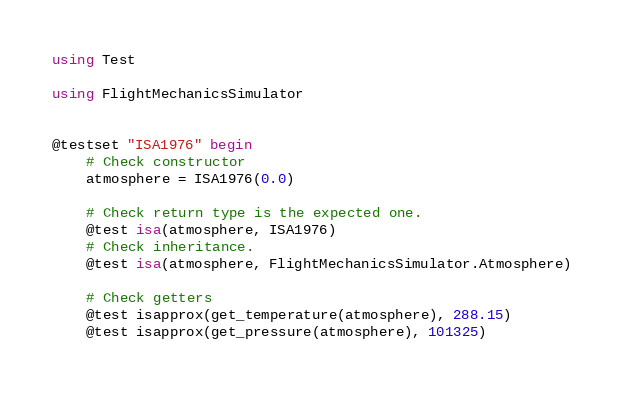<code> <loc_0><loc_0><loc_500><loc_500><_Julia_>using Test

using FlightMechanicsSimulator


@testset "ISA1976" begin
    # Check constructor
    atmosphere = ISA1976(0.0)

    # Check return type is the expected one.
    @test isa(atmosphere, ISA1976)
    # Check inheritance.
    @test isa(atmosphere, FlightMechanicsSimulator.Atmosphere)

    # Check getters
    @test isapprox(get_temperature(atmosphere), 288.15)
    @test isapprox(get_pressure(atmosphere), 101325)</code> 